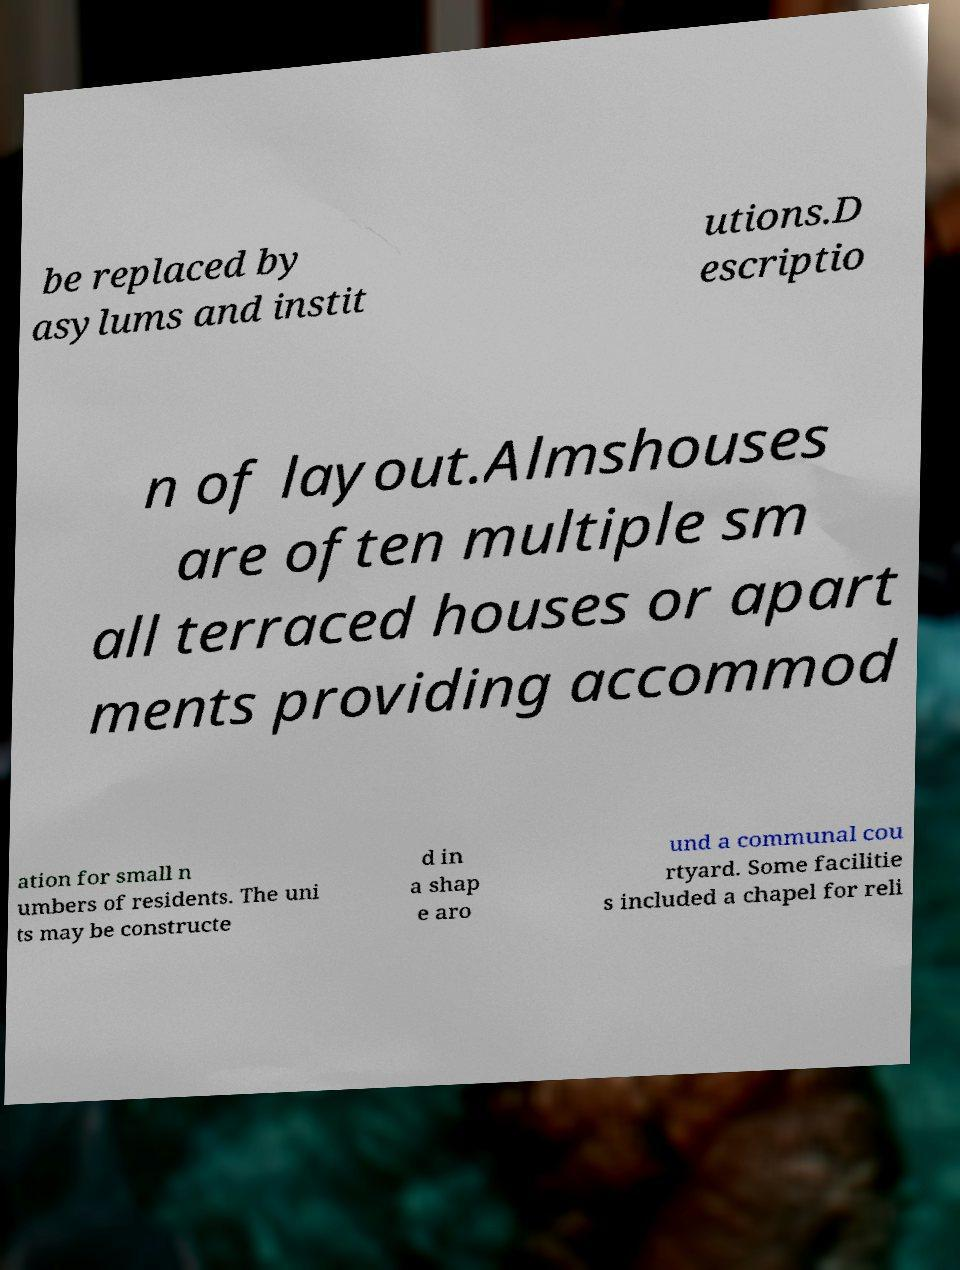Could you extract and type out the text from this image? be replaced by asylums and instit utions.D escriptio n of layout.Almshouses are often multiple sm all terraced houses or apart ments providing accommod ation for small n umbers of residents. The uni ts may be constructe d in a shap e aro und a communal cou rtyard. Some facilitie s included a chapel for reli 